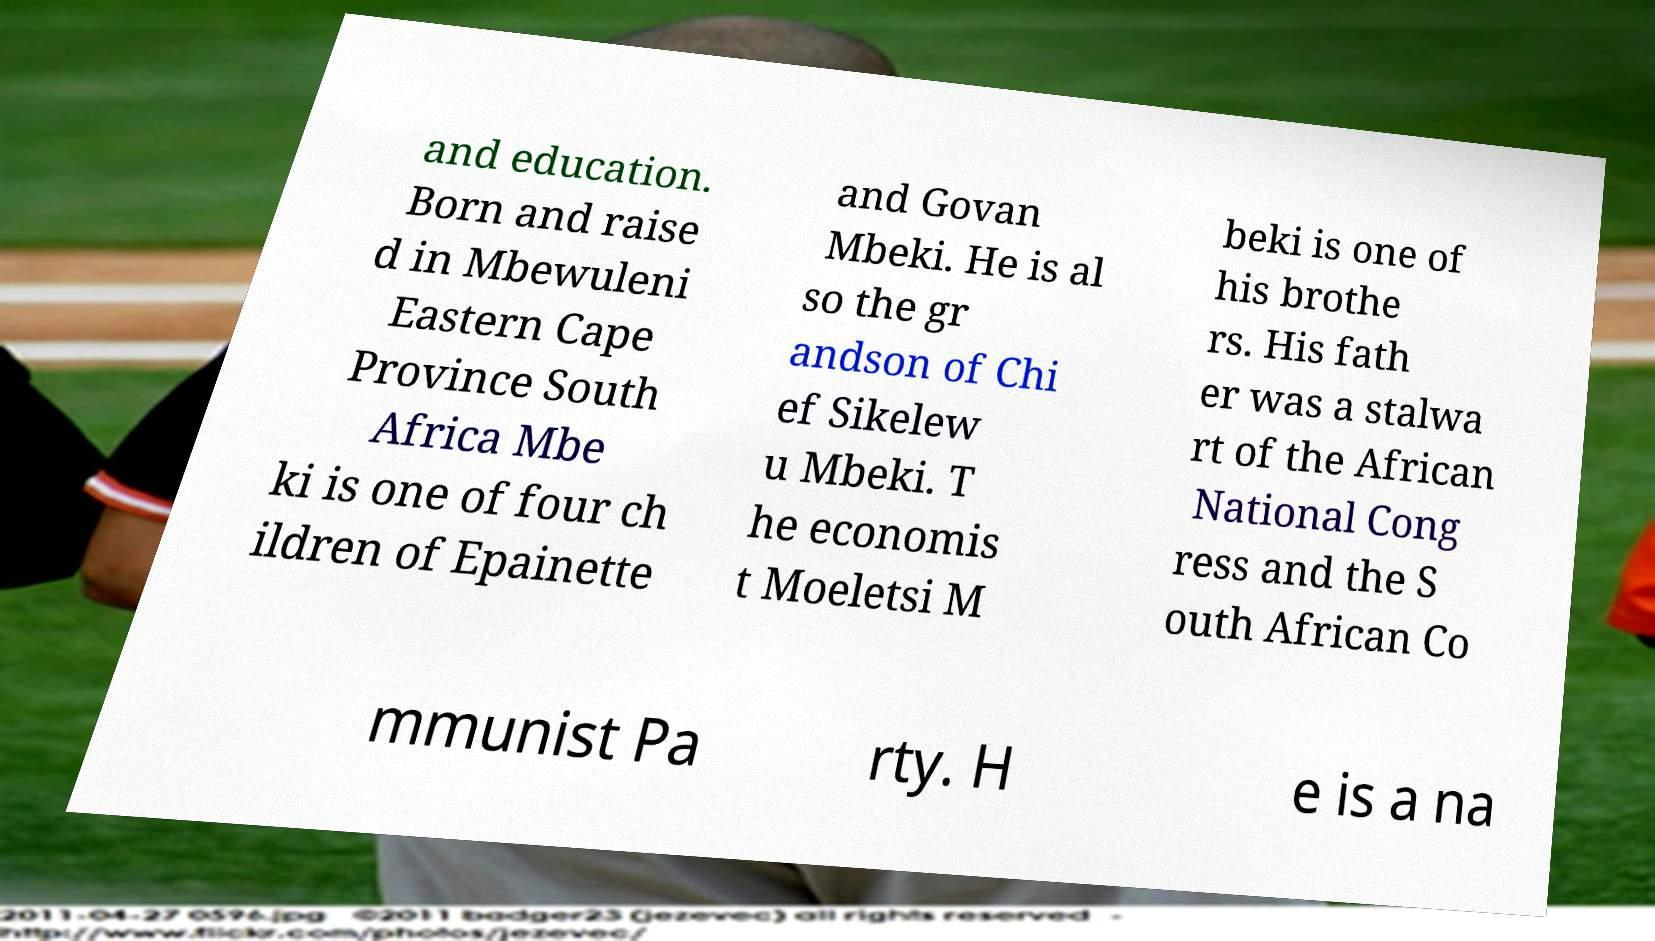Please read and relay the text visible in this image. What does it say? and education. Born and raise d in Mbewuleni Eastern Cape Province South Africa Mbe ki is one of four ch ildren of Epainette and Govan Mbeki. He is al so the gr andson of Chi ef Sikelew u Mbeki. T he economis t Moeletsi M beki is one of his brothe rs. His fath er was a stalwa rt of the African National Cong ress and the S outh African Co mmunist Pa rty. H e is a na 